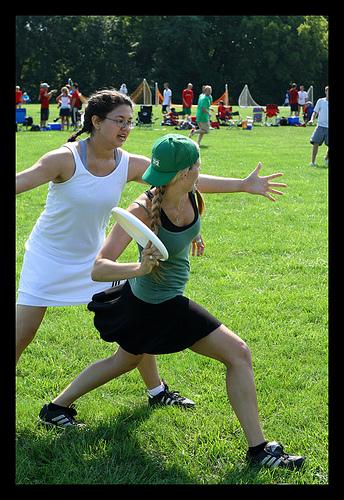What is the girl holding?
Answer briefly. Frisbee. What are the people playing?
Short answer required. Frisbee. Are the two girls on the same team?
Answer briefly. No. 